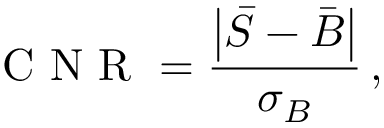Convert formula to latex. <formula><loc_0><loc_0><loc_500><loc_500>C N R = \frac { \left | \bar { S } - \bar { B } \right | } { \sigma _ { B } } \, ,</formula> 